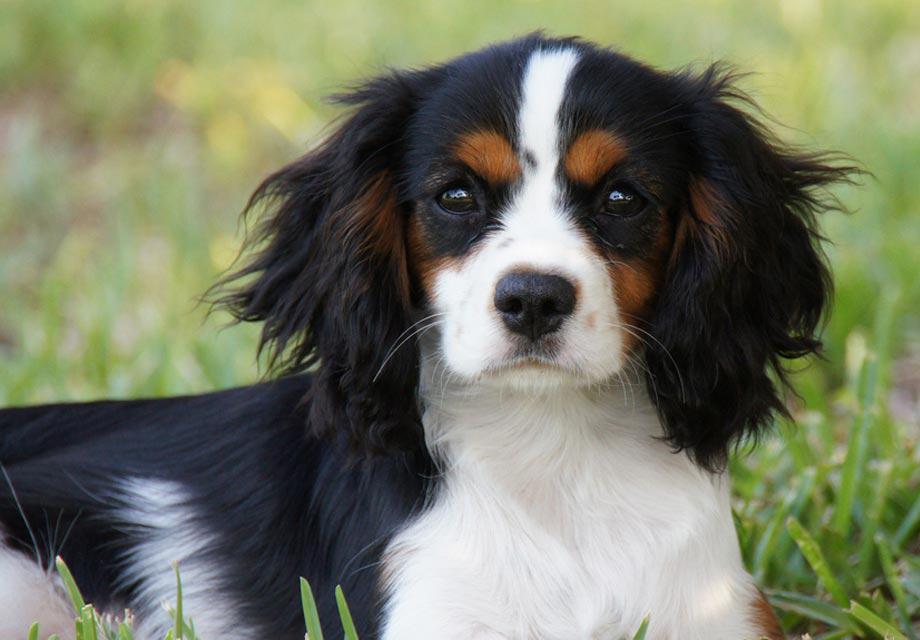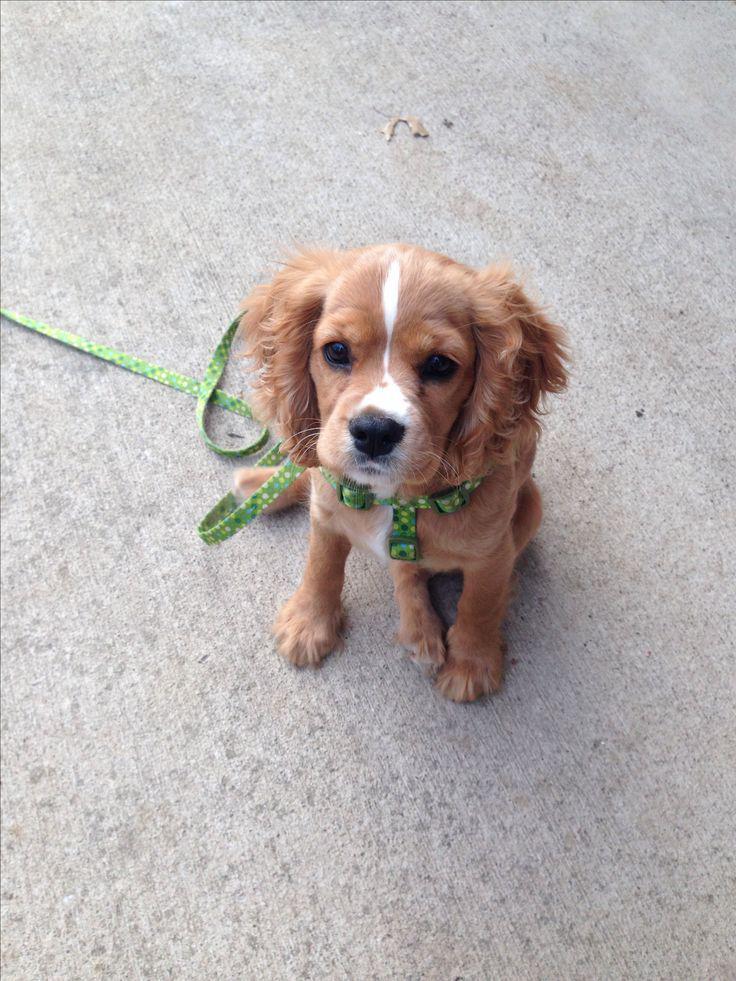The first image is the image on the left, the second image is the image on the right. Analyze the images presented: Is the assertion "The lone dog within the left image is not smiling." valid? Answer yes or no. Yes. The first image is the image on the left, the second image is the image on the right. For the images shown, is this caption "At least one image shows a dog with a dog tag." true? Answer yes or no. No. 